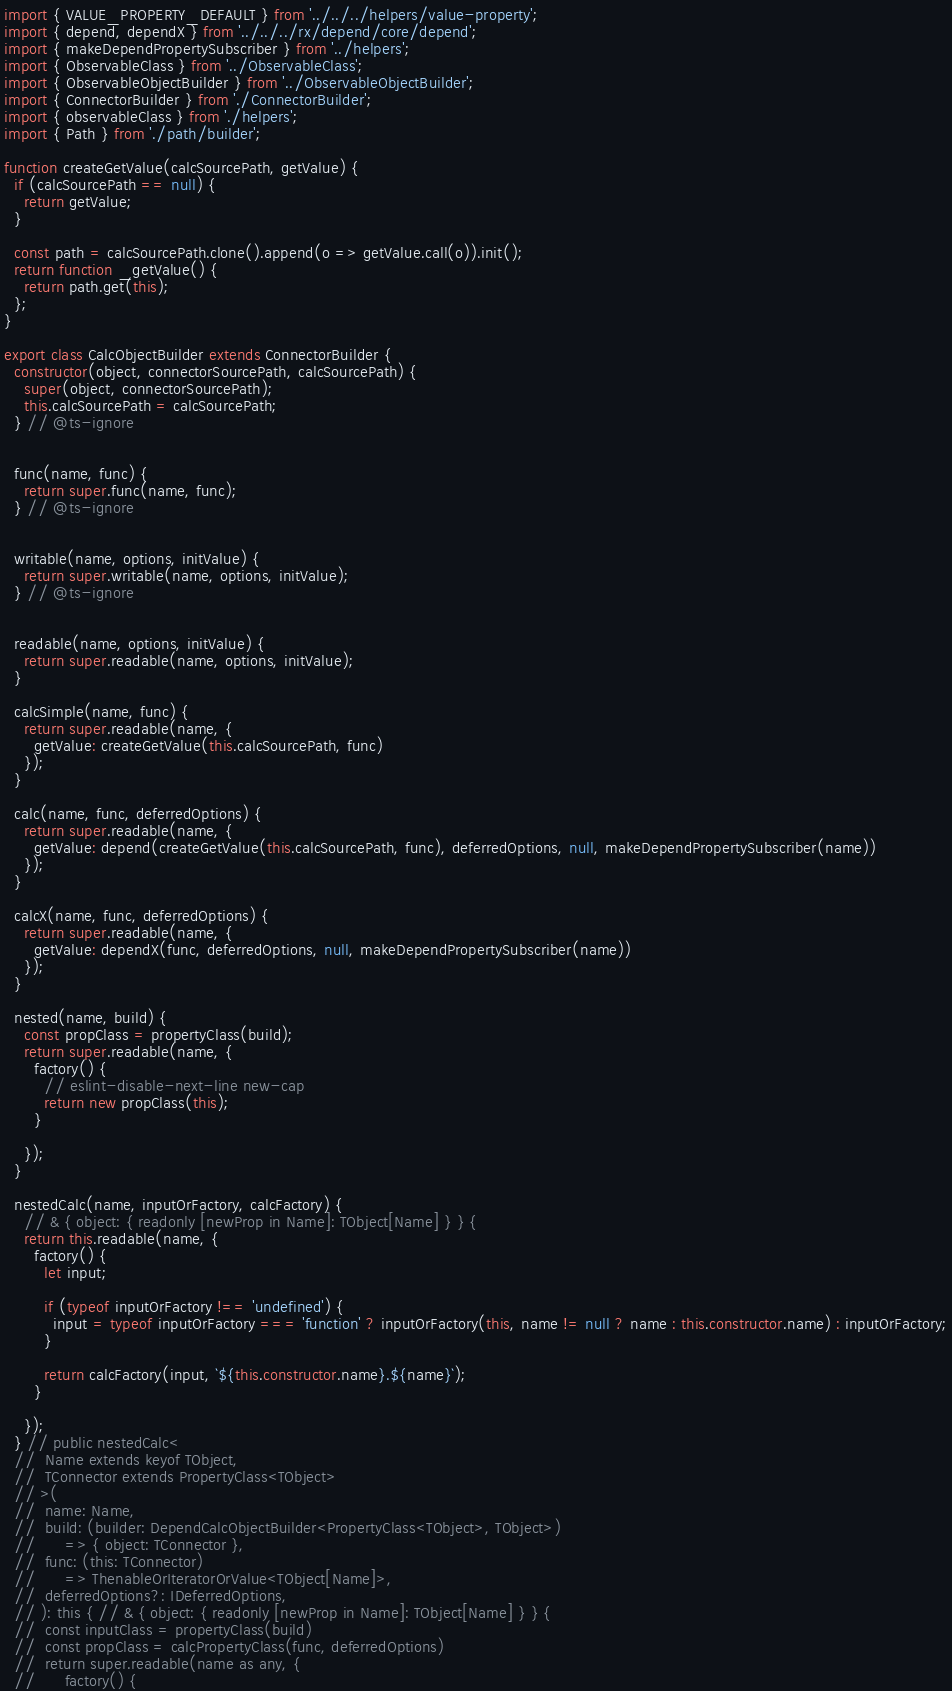<code> <loc_0><loc_0><loc_500><loc_500><_JavaScript_>import { VALUE_PROPERTY_DEFAULT } from '../../../helpers/value-property';
import { depend, dependX } from '../../../rx/depend/core/depend';
import { makeDependPropertySubscriber } from '../helpers';
import { ObservableClass } from '../ObservableClass';
import { ObservableObjectBuilder } from '../ObservableObjectBuilder';
import { ConnectorBuilder } from './ConnectorBuilder';
import { observableClass } from './helpers';
import { Path } from './path/builder';

function createGetValue(calcSourcePath, getValue) {
  if (calcSourcePath == null) {
    return getValue;
  }

  const path = calcSourcePath.clone().append(o => getValue.call(o)).init();
  return function _getValue() {
    return path.get(this);
  };
}

export class CalcObjectBuilder extends ConnectorBuilder {
  constructor(object, connectorSourcePath, calcSourcePath) {
    super(object, connectorSourcePath);
    this.calcSourcePath = calcSourcePath;
  } // @ts-ignore


  func(name, func) {
    return super.func(name, func);
  } // @ts-ignore


  writable(name, options, initValue) {
    return super.writable(name, options, initValue);
  } // @ts-ignore


  readable(name, options, initValue) {
    return super.readable(name, options, initValue);
  }

  calcSimple(name, func) {
    return super.readable(name, {
      getValue: createGetValue(this.calcSourcePath, func)
    });
  }

  calc(name, func, deferredOptions) {
    return super.readable(name, {
      getValue: depend(createGetValue(this.calcSourcePath, func), deferredOptions, null, makeDependPropertySubscriber(name))
    });
  }

  calcX(name, func, deferredOptions) {
    return super.readable(name, {
      getValue: dependX(func, deferredOptions, null, makeDependPropertySubscriber(name))
    });
  }

  nested(name, build) {
    const propClass = propertyClass(build);
    return super.readable(name, {
      factory() {
        // eslint-disable-next-line new-cap
        return new propClass(this);
      }

    });
  }

  nestedCalc(name, inputOrFactory, calcFactory) {
    // & { object: { readonly [newProp in Name]: TObject[Name] } } {
    return this.readable(name, {
      factory() {
        let input;

        if (typeof inputOrFactory !== 'undefined') {
          input = typeof inputOrFactory === 'function' ? inputOrFactory(this, name != null ? name : this.constructor.name) : inputOrFactory;
        }

        return calcFactory(input, `${this.constructor.name}.${name}`);
      }

    });
  } // public nestedCalc<
  // 	Name extends keyof TObject,
  // 	TConnector extends PropertyClass<TObject>
  // >(
  // 	name: Name,
  // 	build: (builder: DependCalcObjectBuilder<PropertyClass<TObject>, TObject>)
  // 		=> { object: TConnector },
  // 	func: (this: TConnector)
  // 		=> ThenableOrIteratorOrValue<TObject[Name]>,
  // 	deferredOptions?: IDeferredOptions,
  // ): this { // & { object: { readonly [newProp in Name]: TObject[Name] } } {
  // 	const inputClass = propertyClass(build)
  // 	const propClass = calcPropertyClass(func, deferredOptions)
  // 	return super.readable(name as any, {
  // 		factory() {</code> 